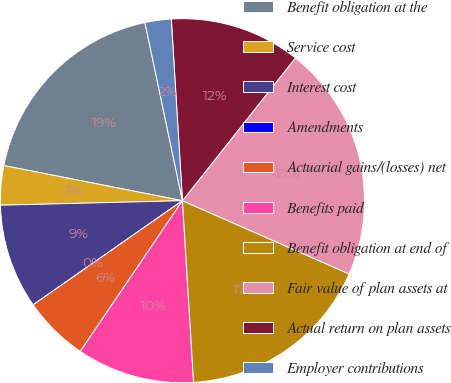<chart> <loc_0><loc_0><loc_500><loc_500><pie_chart><fcel>Benefit obligation at the<fcel>Service cost<fcel>Interest cost<fcel>Amendments<fcel>Actuarial gains/(losses) net<fcel>Benefits paid<fcel>Benefit obligation at end of<fcel>Fair value of plan assets at<fcel>Actual return on plan assets<fcel>Employer contributions<nl><fcel>18.6%<fcel>3.49%<fcel>9.3%<fcel>0.0%<fcel>5.82%<fcel>10.46%<fcel>17.44%<fcel>20.93%<fcel>11.63%<fcel>2.33%<nl></chart> 